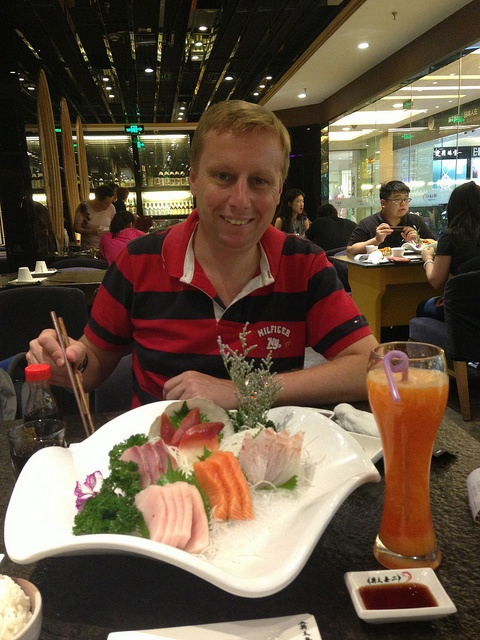Describe the objects in this image and their specific colors. I can see dining table in black, ivory, tan, and darkgreen tones, people in black, maroon, brown, and gray tones, bowl in black, ivory, tan, and darkgreen tones, cup in black, maroon, and brown tones, and dining table in black, olive, maroon, and ivory tones in this image. 